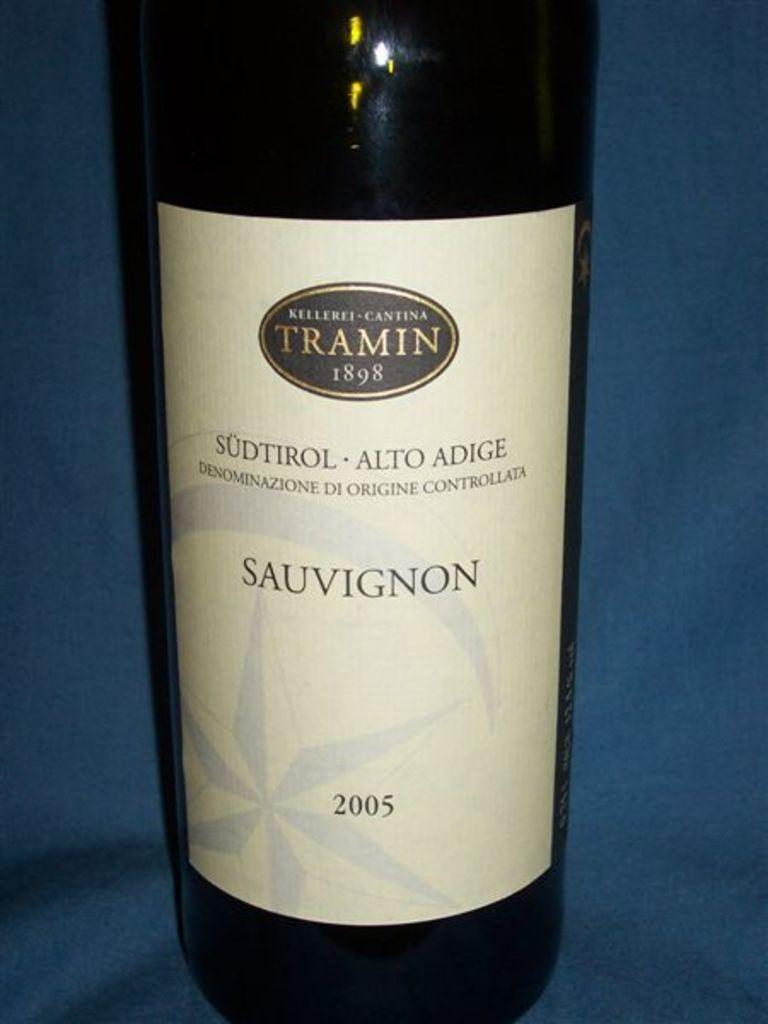<image>
Describe the image concisely. the year of 1898 that is on a wine bottle 